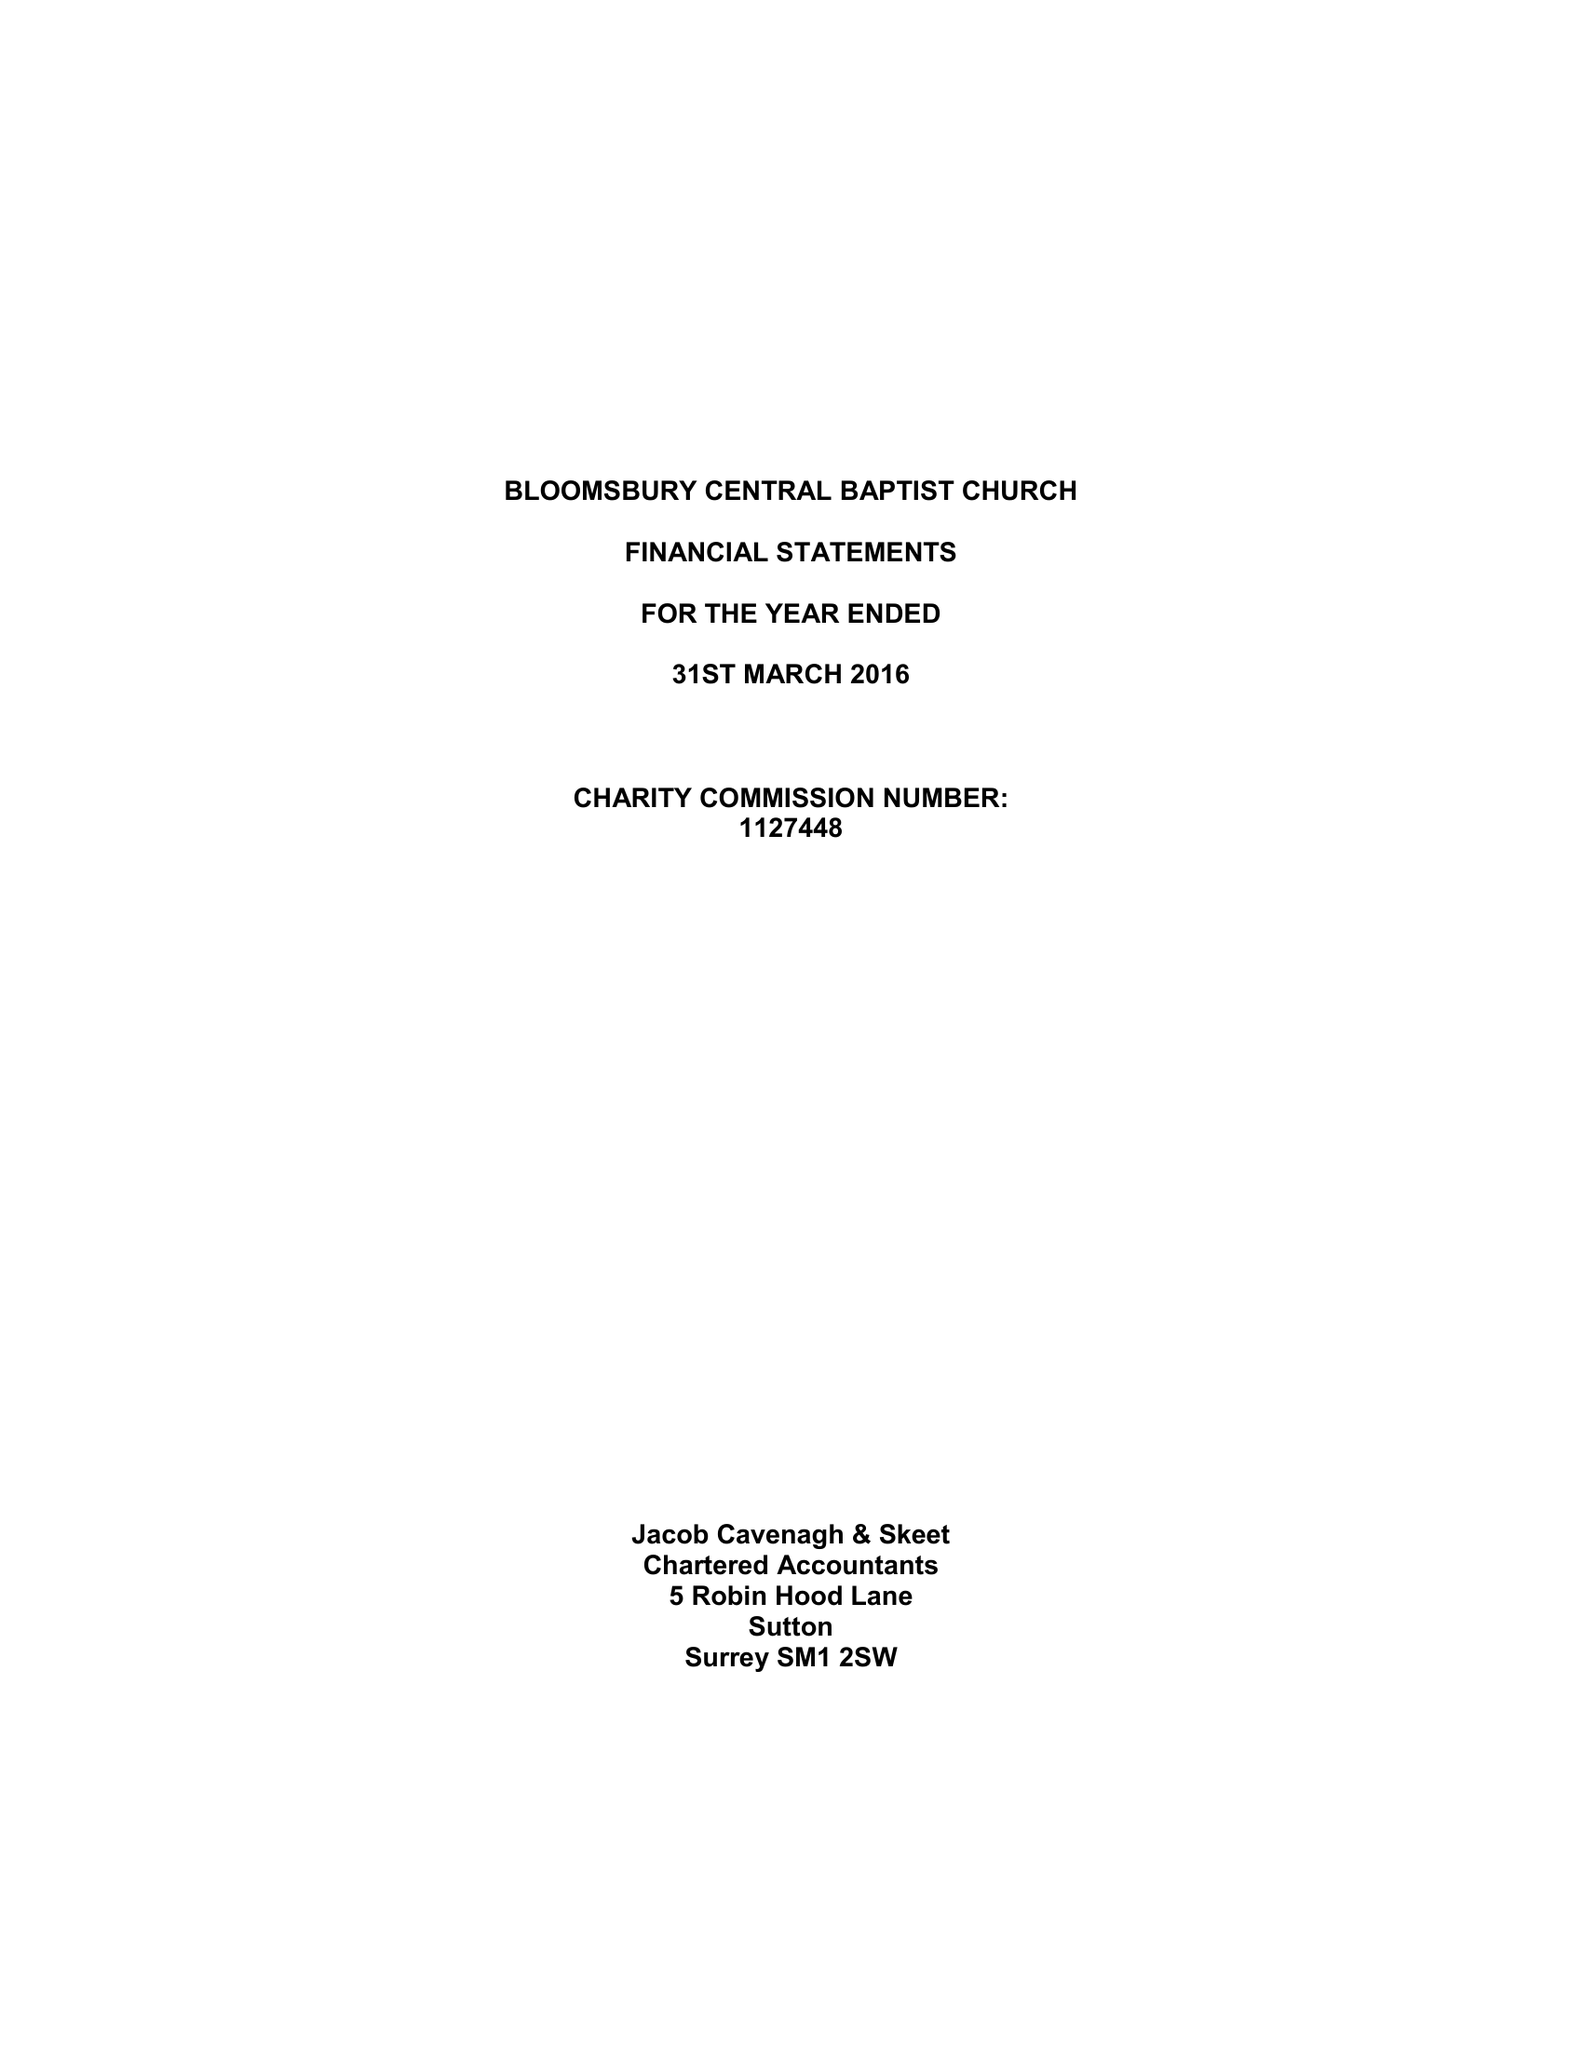What is the value for the income_annually_in_british_pounds?
Answer the question using a single word or phrase. 372247.00 